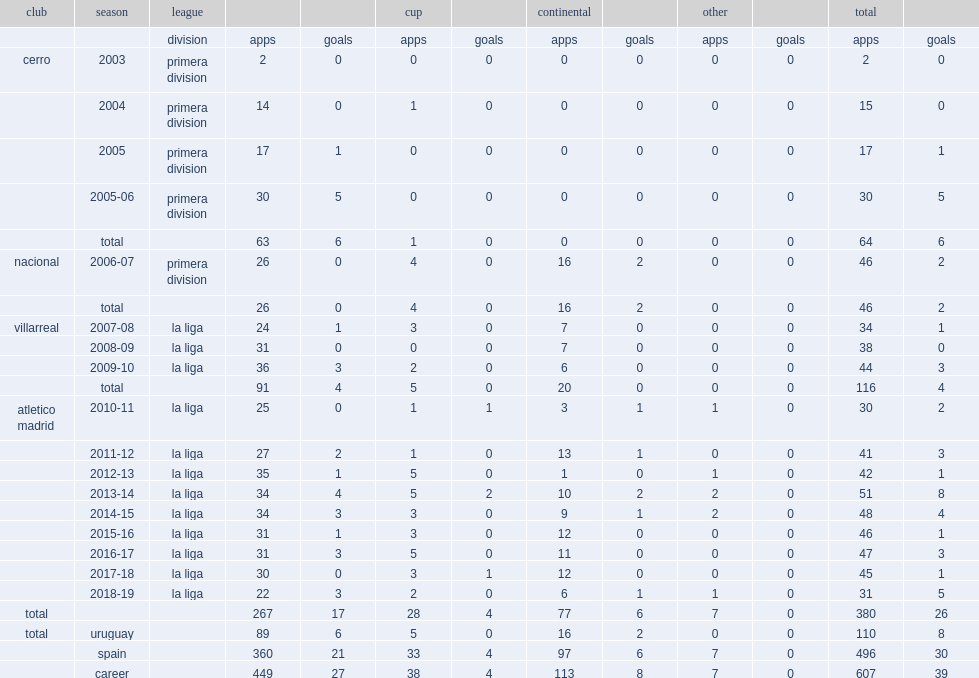Would you be able to parse every entry in this table? {'header': ['club', 'season', 'league', '', '', 'cup', '', 'continental', '', 'other', '', 'total', ''], 'rows': [['', '', 'division', 'apps', 'goals', 'apps', 'goals', 'apps', 'goals', 'apps', 'goals', 'apps', 'goals'], ['cerro', '2003', 'primera division', '2', '0', '0', '0', '0', '0', '0', '0', '2', '0'], ['', '2004', 'primera division', '14', '0', '1', '0', '0', '0', '0', '0', '15', '0'], ['', '2005', 'primera division', '17', '1', '0', '0', '0', '0', '0', '0', '17', '1'], ['', '2005-06', 'primera division', '30', '5', '0', '0', '0', '0', '0', '0', '30', '5'], ['', 'total', '', '63', '6', '1', '0', '0', '0', '0', '0', '64', '6'], ['nacional', '2006-07', 'primera division', '26', '0', '4', '0', '16', '2', '0', '0', '46', '2'], ['', 'total', '', '26', '0', '4', '0', '16', '2', '0', '0', '46', '2'], ['villarreal', '2007-08', 'la liga', '24', '1', '3', '0', '7', '0', '0', '0', '34', '1'], ['', '2008-09', 'la liga', '31', '0', '0', '0', '7', '0', '0', '0', '38', '0'], ['', '2009-10', 'la liga', '36', '3', '2', '0', '6', '0', '0', '0', '44', '3'], ['', 'total', '', '91', '4', '5', '0', '20', '0', '0', '0', '116', '4'], ['atletico madrid', '2010-11', 'la liga', '25', '0', '1', '1', '3', '1', '1', '0', '30', '2'], ['', '2011-12', 'la liga', '27', '2', '1', '0', '13', '1', '0', '0', '41', '3'], ['', '2012-13', 'la liga', '35', '1', '5', '0', '1', '0', '1', '0', '42', '1'], ['', '2013-14', 'la liga', '34', '4', '5', '2', '10', '2', '2', '0', '51', '8'], ['', '2014-15', 'la liga', '34', '3', '3', '0', '9', '1', '2', '0', '48', '4'], ['', '2015-16', 'la liga', '31', '1', '3', '0', '12', '0', '0', '0', '46', '1'], ['', '2016-17', 'la liga', '31', '3', '5', '0', '11', '0', '0', '0', '47', '3'], ['', '2017-18', 'la liga', '30', '0', '3', '1', '12', '0', '0', '0', '45', '1'], ['', '2018-19', 'la liga', '22', '3', '2', '0', '6', '1', '1', '0', '31', '5'], ['total', '', '', '267', '17', '28', '4', '77', '6', '7', '0', '380', '26'], ['total', 'uruguay', '', '89', '6', '5', '0', '16', '2', '0', '0', '110', '8'], ['', 'spain', '', '360', '21', '33', '4', '97', '6', '7', '0', '496', '30'], ['', 'career', '', '449', '27', '38', '4', '113', '8', '7', '0', '607', '39']]} Which club did diego godin play for in 2013-14? Atletico madrid. 